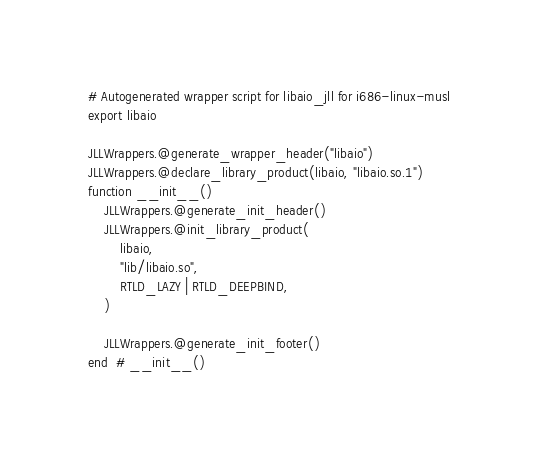Convert code to text. <code><loc_0><loc_0><loc_500><loc_500><_Julia_># Autogenerated wrapper script for libaio_jll for i686-linux-musl
export libaio

JLLWrappers.@generate_wrapper_header("libaio")
JLLWrappers.@declare_library_product(libaio, "libaio.so.1")
function __init__()
    JLLWrappers.@generate_init_header()
    JLLWrappers.@init_library_product(
        libaio,
        "lib/libaio.so",
        RTLD_LAZY | RTLD_DEEPBIND,
    )

    JLLWrappers.@generate_init_footer()
end  # __init__()
</code> 